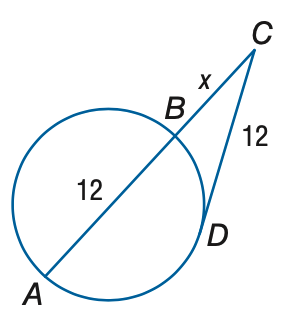Question: Find x to the nearest tenth. Assume that segments that appear to be tangent are tangent.
Choices:
A. 7.4
B. 7.9
C. 8.4
D. 8.9
Answer with the letter. Answer: A 